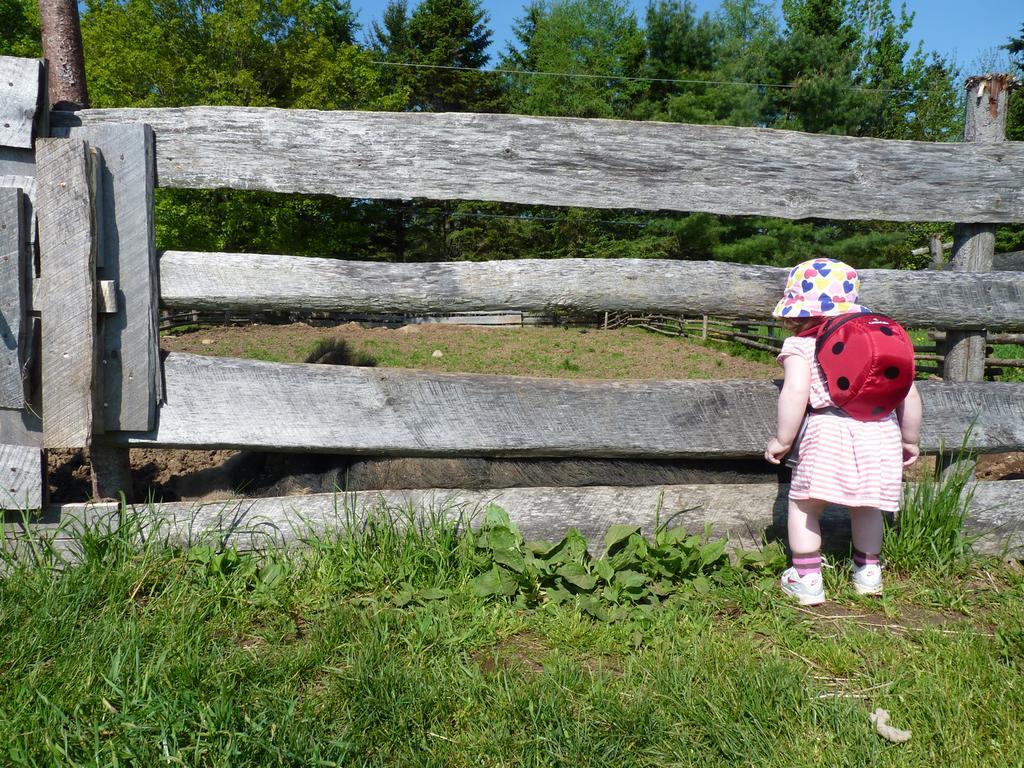In one or two sentences, can you explain what this image depicts? To the right side of the image there is a girl wearing a bag. In the center of the image there is a fencing. At the bottom of the image there is grass. In the background of the image there are trees and sky. 